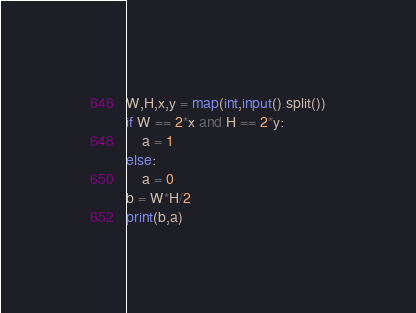Convert code to text. <code><loc_0><loc_0><loc_500><loc_500><_Python_>W,H,x,y = map(int,input().split())
if W == 2*x and H == 2*y:
    a = 1
else:
    a = 0
b = W*H/2
print(b,a)
</code> 